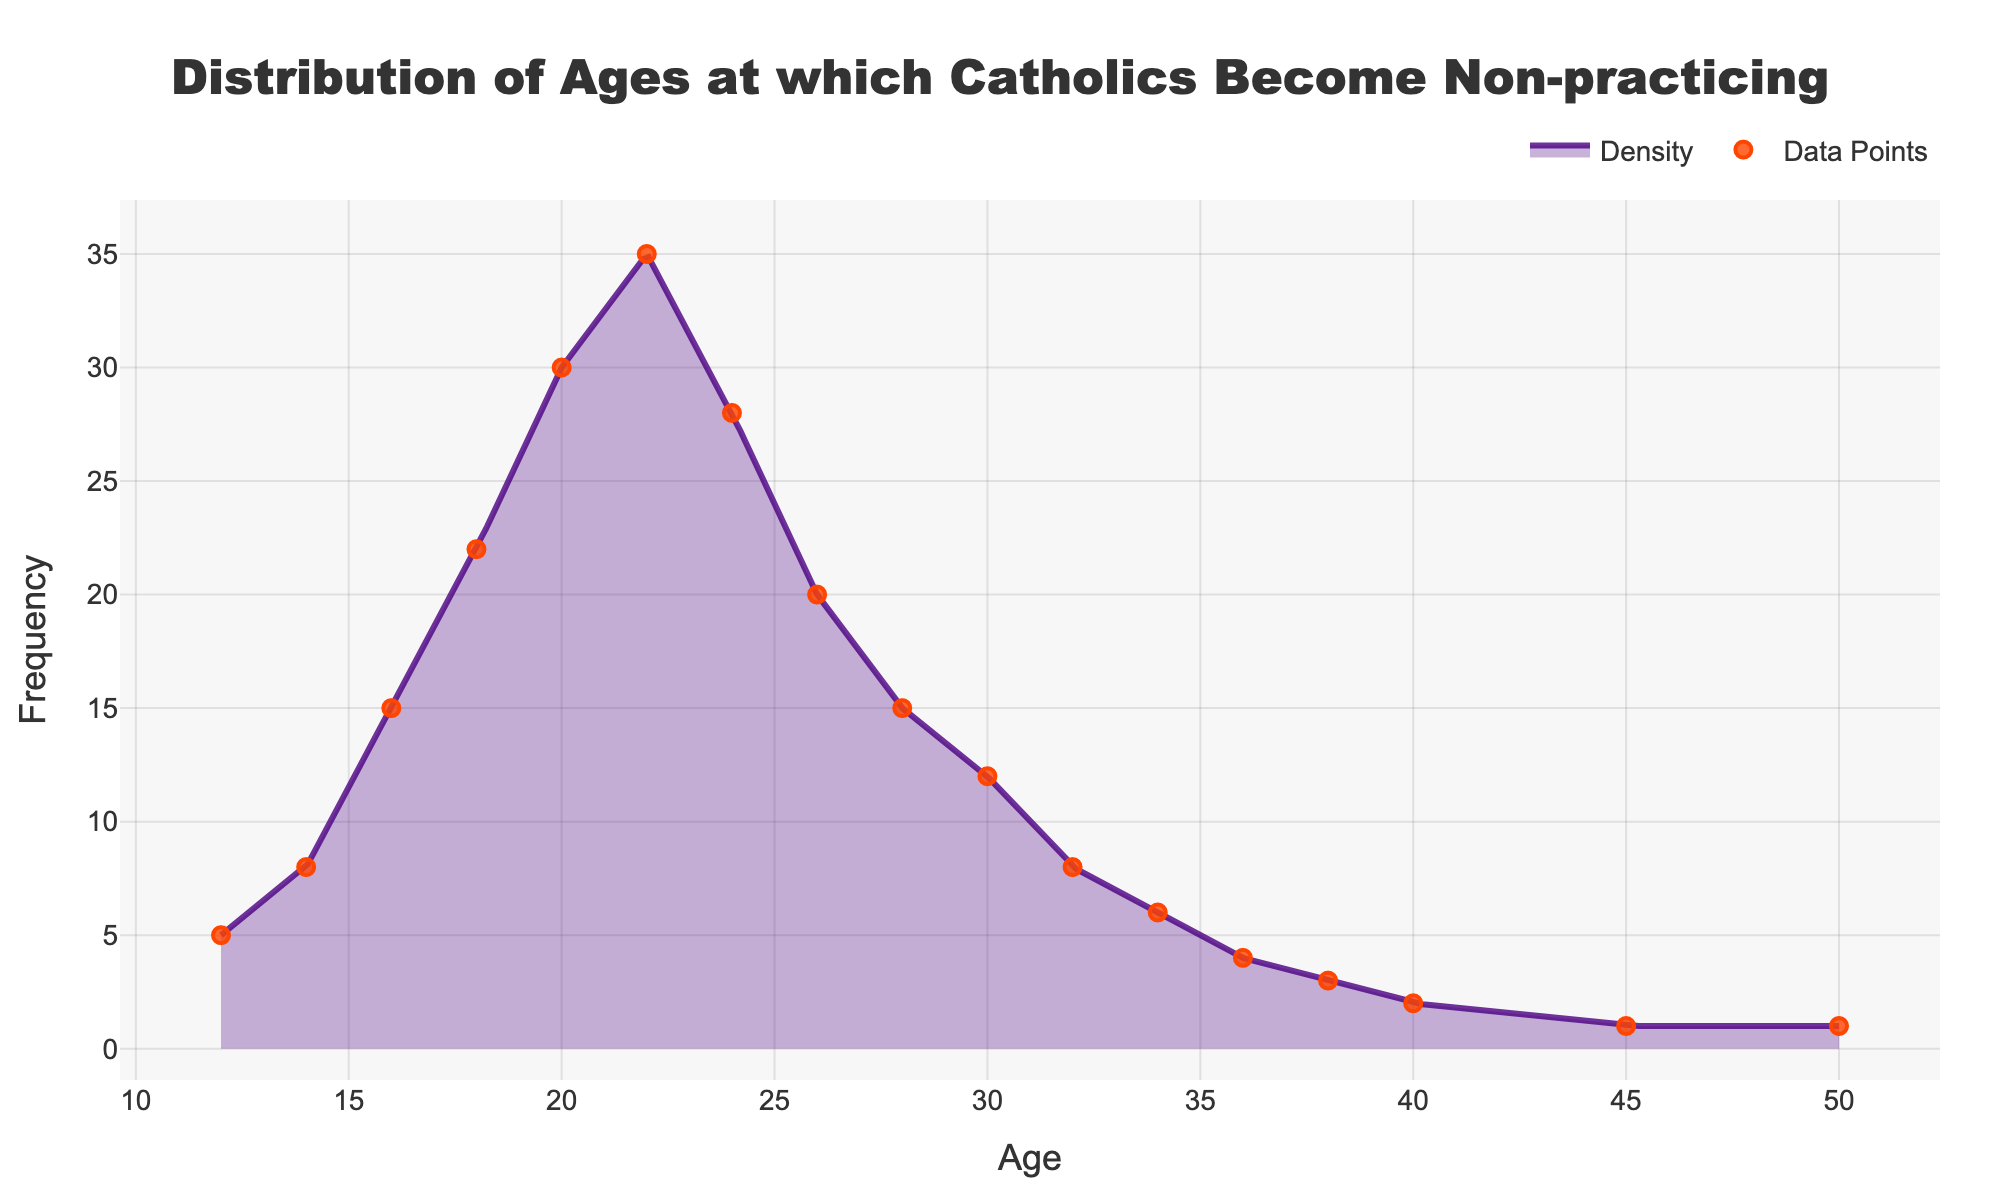What is the title of the plot? The title of the plot is clearly written at the top center of the figure.
Answer: Distribution of Ages at which Catholics Become Non-practicing What does the x-axis represent in the plot? The x-axis represents the variable that is being plotted against the frequency, and it is labeled accordingly.
Answer: Age What is the maximum frequency observed in the plot? By looking at the density curve, you can identify the highest point on the y-axis, which represents the maximum frequency.
Answer: 35 At what age does the frequency of becoming non-practicing Catholics peak? The peak of the density plot indicates the age at which the frequency is the highest.
Answer: 22 How many distinct ages are marked as data points in the plot? Count the individual markers on the plot representing the actual data points.
Answer: 17 Around which age range does the frequency start to decline rapidly after the peak? Observe the shape of the density plot and note the age range just after the peak where the frequency drops most noticeably.
Answer: 24-26 By how much does the frequency decrease from age 24 to 28? Compare the frequency values at ages 24 and 28 by looking at the y-axis values for these ages and subtracting them.
Answer: 13 Is there another noticeable increase or secondary peak in the frequency distribution? Look for any smaller peaks or upticks in the density curve after the main peak.
Answer: No At what age does the frequency drop to nearly zero? Identify the age at which the density plot nearly touches the bottom of the y-axis.
Answer: Around 45 How does the frequency at age 30 compare to the frequency at age 20? Compare the y-values at the ages 30 and 20 directly from the plot.
Answer: Frequency at age 30 is lower than at age 20 